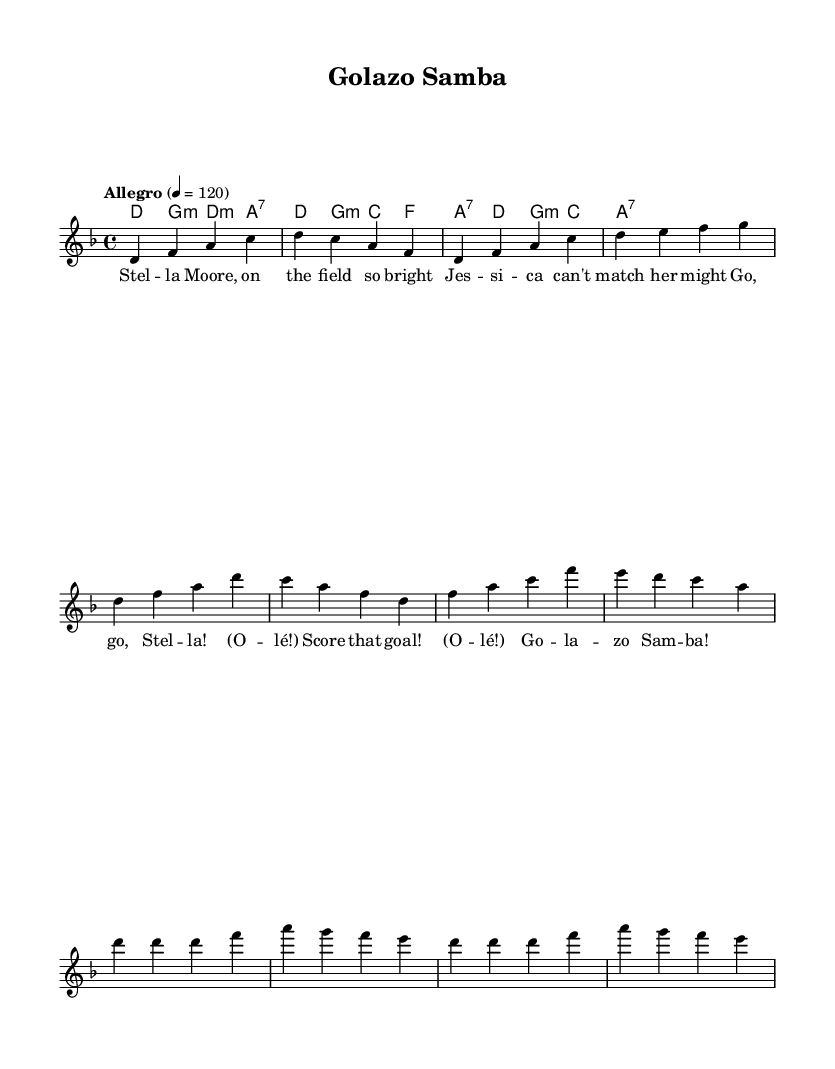What is the key signature of this music? The key signature indicates the music is in D minor, which typically has one flat (B flat).
Answer: D minor What is the time signature of this piece? The time signature shown in the music is 4/4, which means there are four beats in each measure and the quarter note gets one beat.
Answer: 4/4 What is the tempo marking for this composition? The tempo marking is marked as "Allegro," indicating a fast and lively pace with a metronome marking of 120 beats per minute.
Answer: Allegro How many measures are there in the melody's verse section? The verse section comprises four measures, as indicated by the notation in the score.
Answer: 4 Which instrument is primarily featured in the score? The lead voice is notated specifically in the sheet, indicating the instrument or vocal part is the primary focus of the score.
Answer: Lead voice What unique rhythmic element does the chorus incorporate from football chants? The chorus incorporates repetitive phrases, typical of football chants, using "Go" and "O-lé!" to create a call-and-response style typical in chants.
Answer: Call-and-response How does the harmony change between the verse and chorus sections? The harmony transitions from minor chords in the verse to a more repetitive and straightforward structure in the chorus, creating an uplifting feel.
Answer: Repetitive structure 